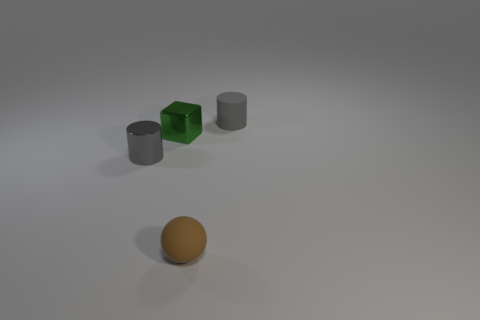Does the shiny cube have the same color as the rubber thing that is in front of the small gray matte thing?
Provide a succinct answer. No. What is the shape of the brown thing?
Provide a short and direct response. Sphere. Is the color of the ball the same as the block?
Ensure brevity in your answer.  No. What number of objects are either objects on the left side of the rubber cylinder or tiny gray cylinders?
Provide a succinct answer. 4. There is a object that is the same material as the green block; what size is it?
Provide a short and direct response. Small. Are there more small green metal blocks that are on the left side of the small ball than brown matte cylinders?
Offer a terse response. Yes. There is a tiny green thing; does it have the same shape as the small metallic thing that is in front of the green metal block?
Your response must be concise. No. What number of small things are gray things or green metallic blocks?
Ensure brevity in your answer.  3. There is a metal cylinder that is the same color as the matte cylinder; what size is it?
Keep it short and to the point. Small. What color is the small sphere that is in front of the tiny gray cylinder behind the tiny shiny cube?
Your answer should be very brief. Brown. 